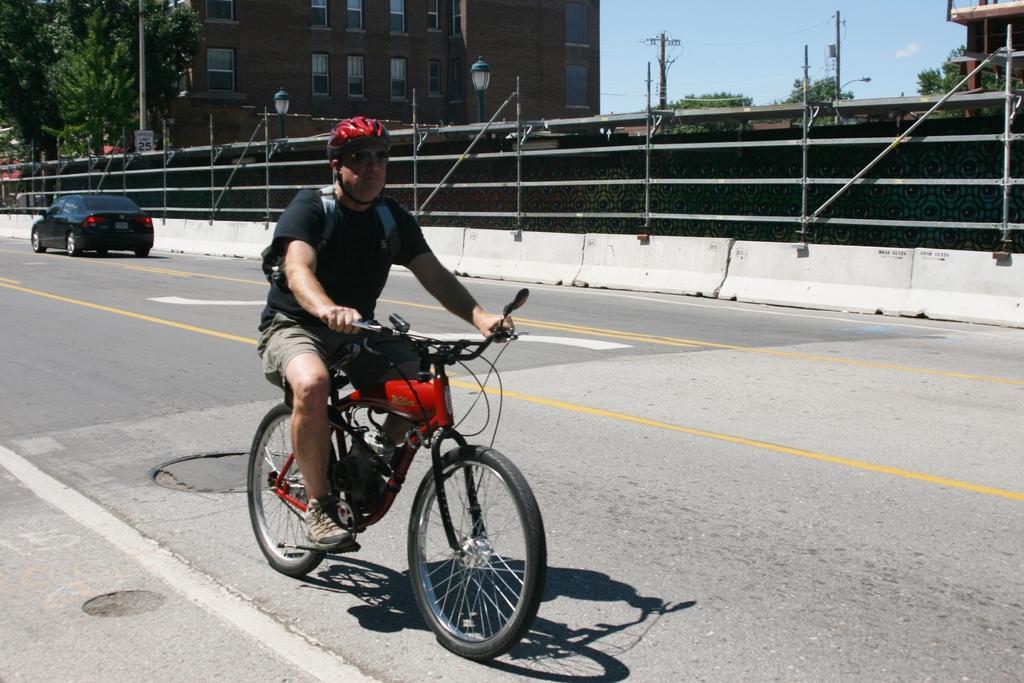Could you give a brief overview of what you see in this image? There is a man on the bicycle. This is road. Here we can see a car. This is building and there are trees. And this is pole. 